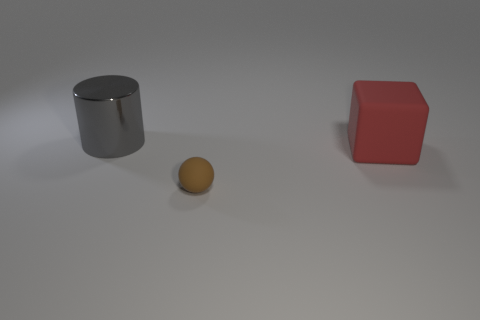Are there any purple cubes made of the same material as the sphere? no 